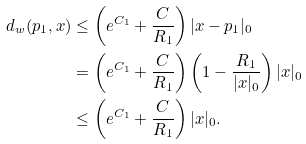Convert formula to latex. <formula><loc_0><loc_0><loc_500><loc_500>d _ { w } ( p _ { 1 } , x ) & \leq \left ( e ^ { C _ { 1 } } + \frac { C } { R _ { 1 } } \right ) | x - p _ { 1 } | _ { 0 } \\ & = \left ( e ^ { C _ { 1 } } + \frac { C } { R _ { 1 } } \right ) \left ( 1 - \frac { R _ { 1 } } { | x | _ { 0 } } \right ) | x | _ { 0 } \\ & \leq \left ( e ^ { C _ { 1 } } + \frac { C } { R _ { 1 } } \right ) | x | _ { 0 } .</formula> 